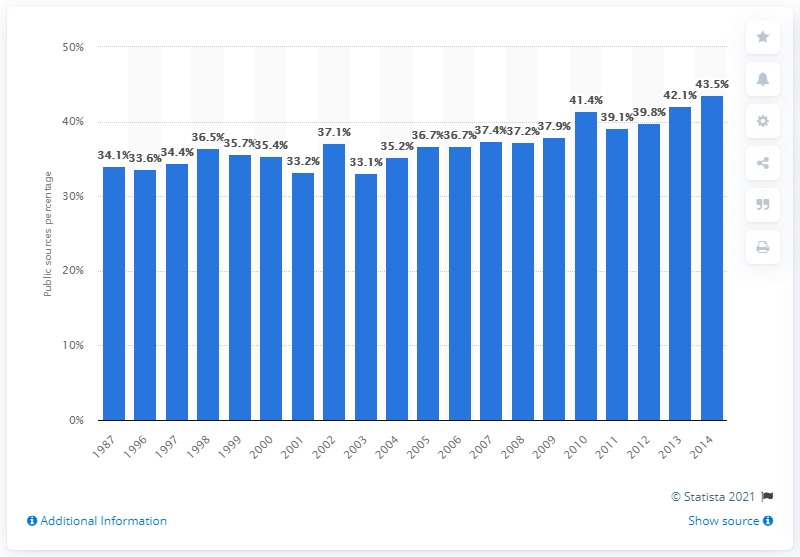Specify some key components in this picture. In 2014, the proportion of public sector payments in the United States was 43.5%. 